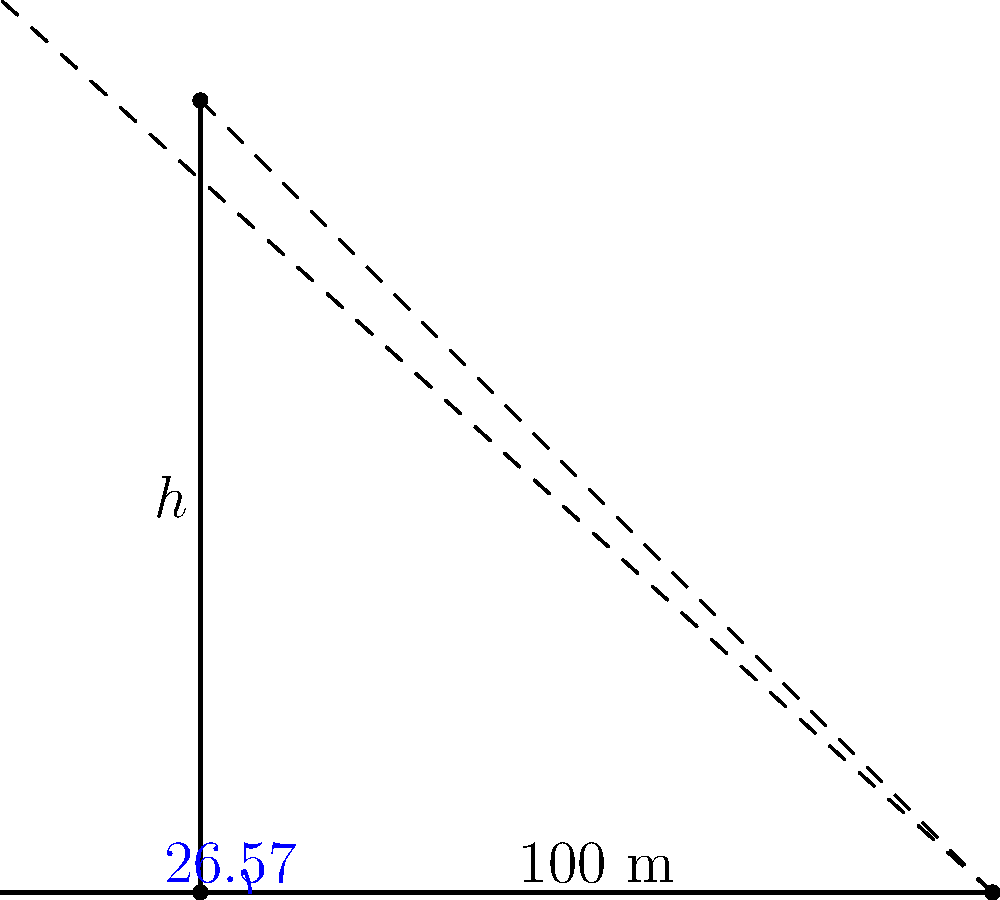A business intelligence analyst is tasked with determining the height of a skyscraper for a real estate analysis project. At a certain time of day, the skyscraper casts a shadow that is 100 meters long. The angle of elevation of the sun at that time is measured to be 26.57°. Using trigonometric ratios, calculate the height of the skyscraper to the nearest meter. Let's approach this step-by-step:

1) We can model this scenario as a right-angled triangle, where:
   - The shadow length is the base of the triangle
   - The height of the skyscraper is the perpendicular side
   - The sun's rays form the hypotenuse

2) We're given:
   - The angle of elevation: $\theta = 26.57°$
   - The length of the shadow: $100$ meters

3) We need to find the height of the skyscraper. Let's call this $h$.

4) In this right-angled triangle, we can see that:
   $\tan(\theta) = \frac{\text{opposite}}{\text{adjacent}} = \frac{h}{100}$

5) Therefore:
   $h = 100 \times \tan(26.57°)$

6) Using a calculator or programming function:
   $h = 100 \times 0.4999 = 49.99$ meters

7) Rounding to the nearest meter:
   $h \approx 50$ meters

This method uses the tangent ratio, which is particularly useful when we know the angle and the length of the side adjacent to the angle in a right-angled triangle.
Answer: 50 meters 